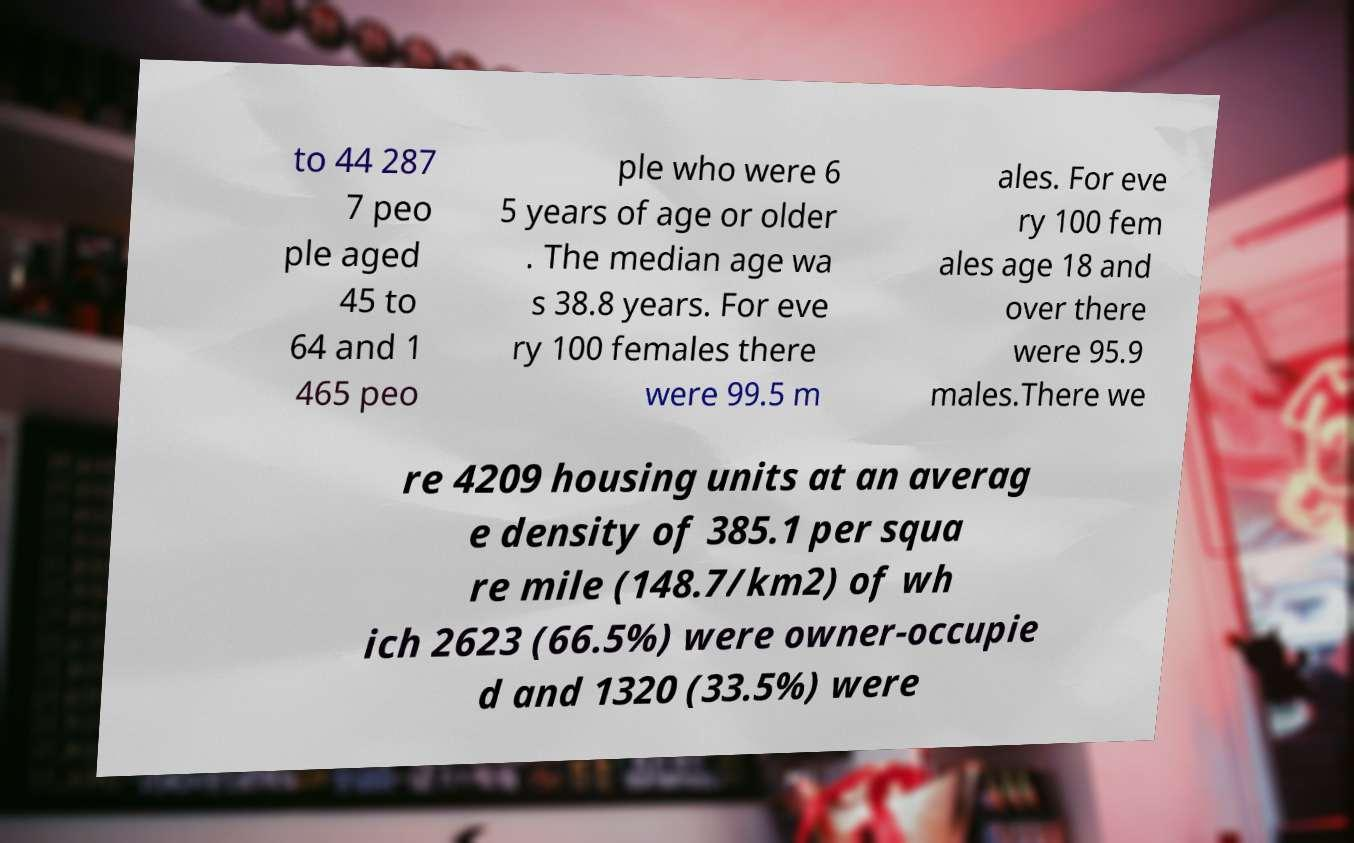Could you extract and type out the text from this image? to 44 287 7 peo ple aged 45 to 64 and 1 465 peo ple who were 6 5 years of age or older . The median age wa s 38.8 years. For eve ry 100 females there were 99.5 m ales. For eve ry 100 fem ales age 18 and over there were 95.9 males.There we re 4209 housing units at an averag e density of 385.1 per squa re mile (148.7/km2) of wh ich 2623 (66.5%) were owner-occupie d and 1320 (33.5%) were 